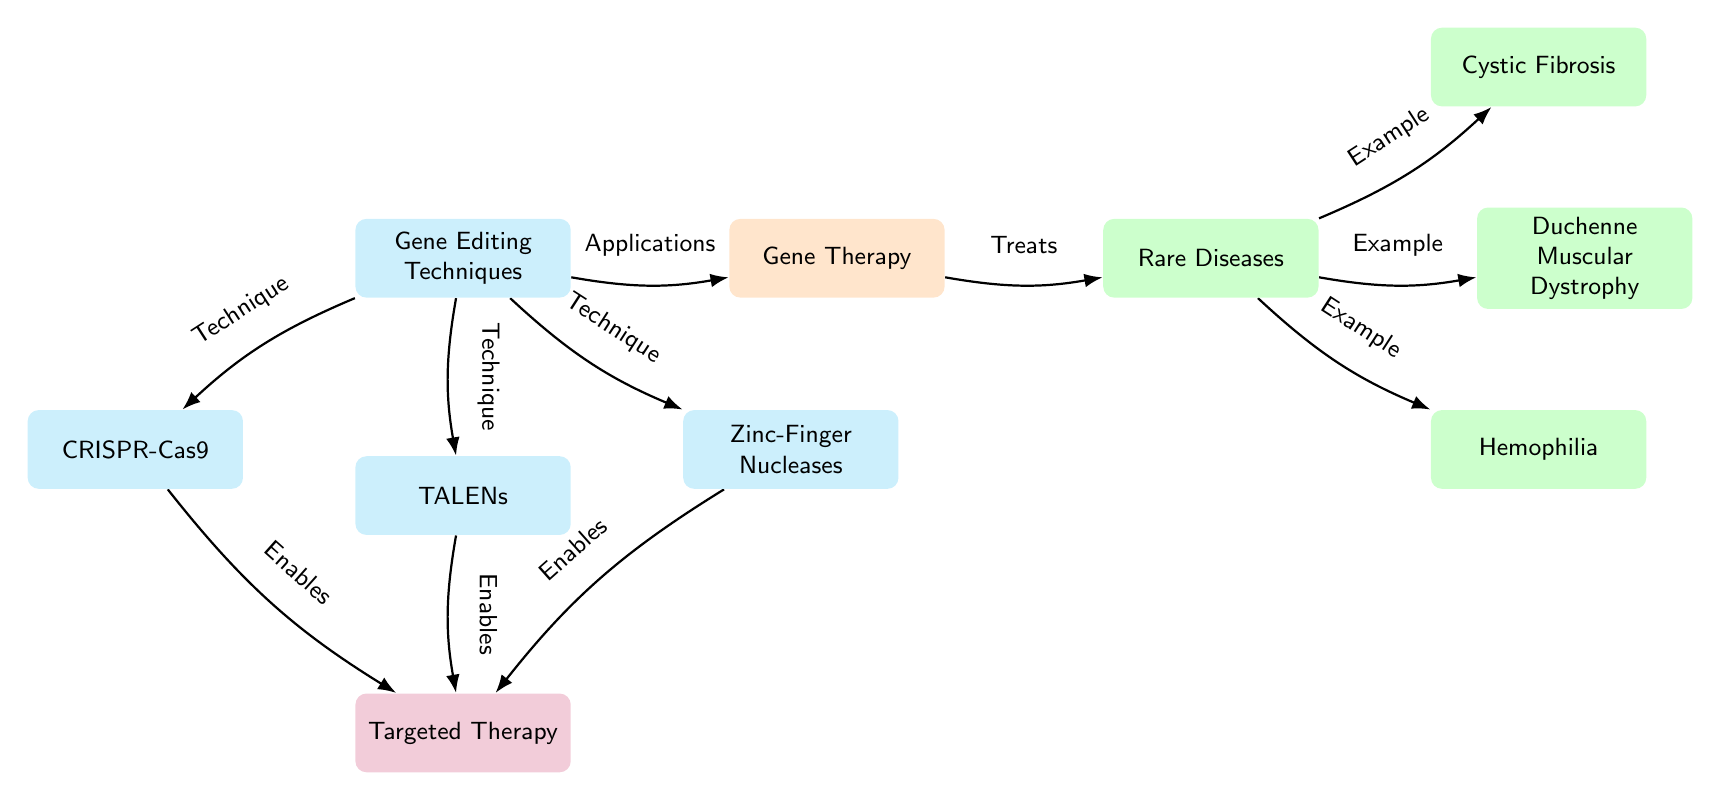What are the gene editing techniques mentioned in the diagram? The diagram lists three specific gene editing techniques: CRISPR-Cas9, TALENs, and Zinc-Finger Nucleases. All three are the nodes connected under the "Gene Editing Techniques" node.
Answer: CRISPR-Cas9, TALENs, Zinc-Finger Nucleases How many rare diseases are mentioned in relation to gene therapy? There are three rare diseases mentioned: Cystic Fibrosis, Duchenne Muscular Dystrophy, and Hemophilia, each represented as nodes branching from the "Rare Diseases" node.
Answer: 3 What enables targeted therapy in the context of gene editing techniques? Targeted therapy is enabled by all three gene editing techniques (CRISPR-Cas9, TALENs, and Zinc-Finger Nucleases). The arrows indicate that each technique connects directly to the targeted therapy node under the gene editing techniques.
Answer: CRISPR-Cas9, TALENs, Zinc-Finger Nucleases What is the primary application of gene editing techniques shown in the diagram? The primary application of gene editing techniques, as indicated in the diagram, is Gene Therapy. It is connected to the "Gene Editing Techniques" node directly, suggesting it is the main application derived from those techniques.
Answer: Gene Therapy Which rare disease is listed first in the diagram? The first rare disease listed in the diagram, when moving from the "Rare Diseases" node, is Cystic Fibrosis. This is positioned at the top right of the node for rare diseases, indicating its priority.
Answer: Cystic Fibrosis What type of therapy is associated with gene editing techniques according to the diagram? The diagram associates "Targeted Therapy" with the three gene editing techniques. Arrows from each editing technique point toward the targeted therapy node, signifying its connection.
Answer: Targeted Therapy 